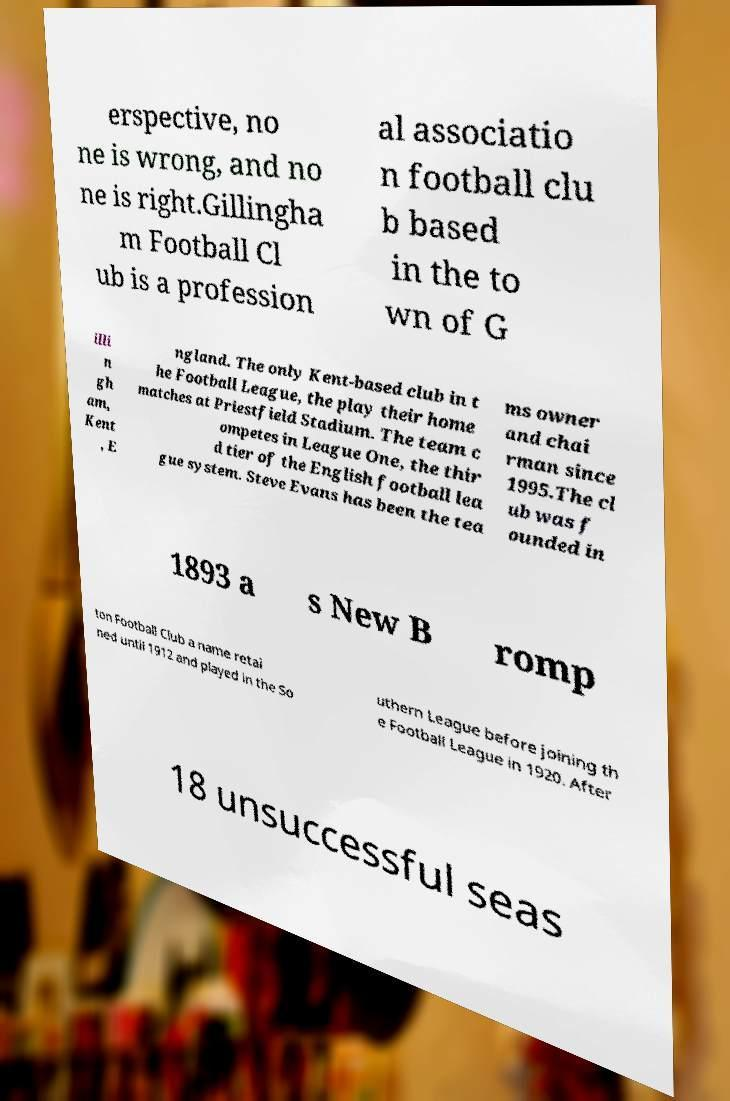Could you assist in decoding the text presented in this image and type it out clearly? erspective, no ne is wrong, and no ne is right.Gillingha m Football Cl ub is a profession al associatio n football clu b based in the to wn of G illi n gh am, Kent , E ngland. The only Kent-based club in t he Football League, the play their home matches at Priestfield Stadium. The team c ompetes in League One, the thir d tier of the English football lea gue system. Steve Evans has been the tea ms owner and chai rman since 1995.The cl ub was f ounded in 1893 a s New B romp ton Football Club a name retai ned until 1912 and played in the So uthern League before joining th e Football League in 1920. After 18 unsuccessful seas 